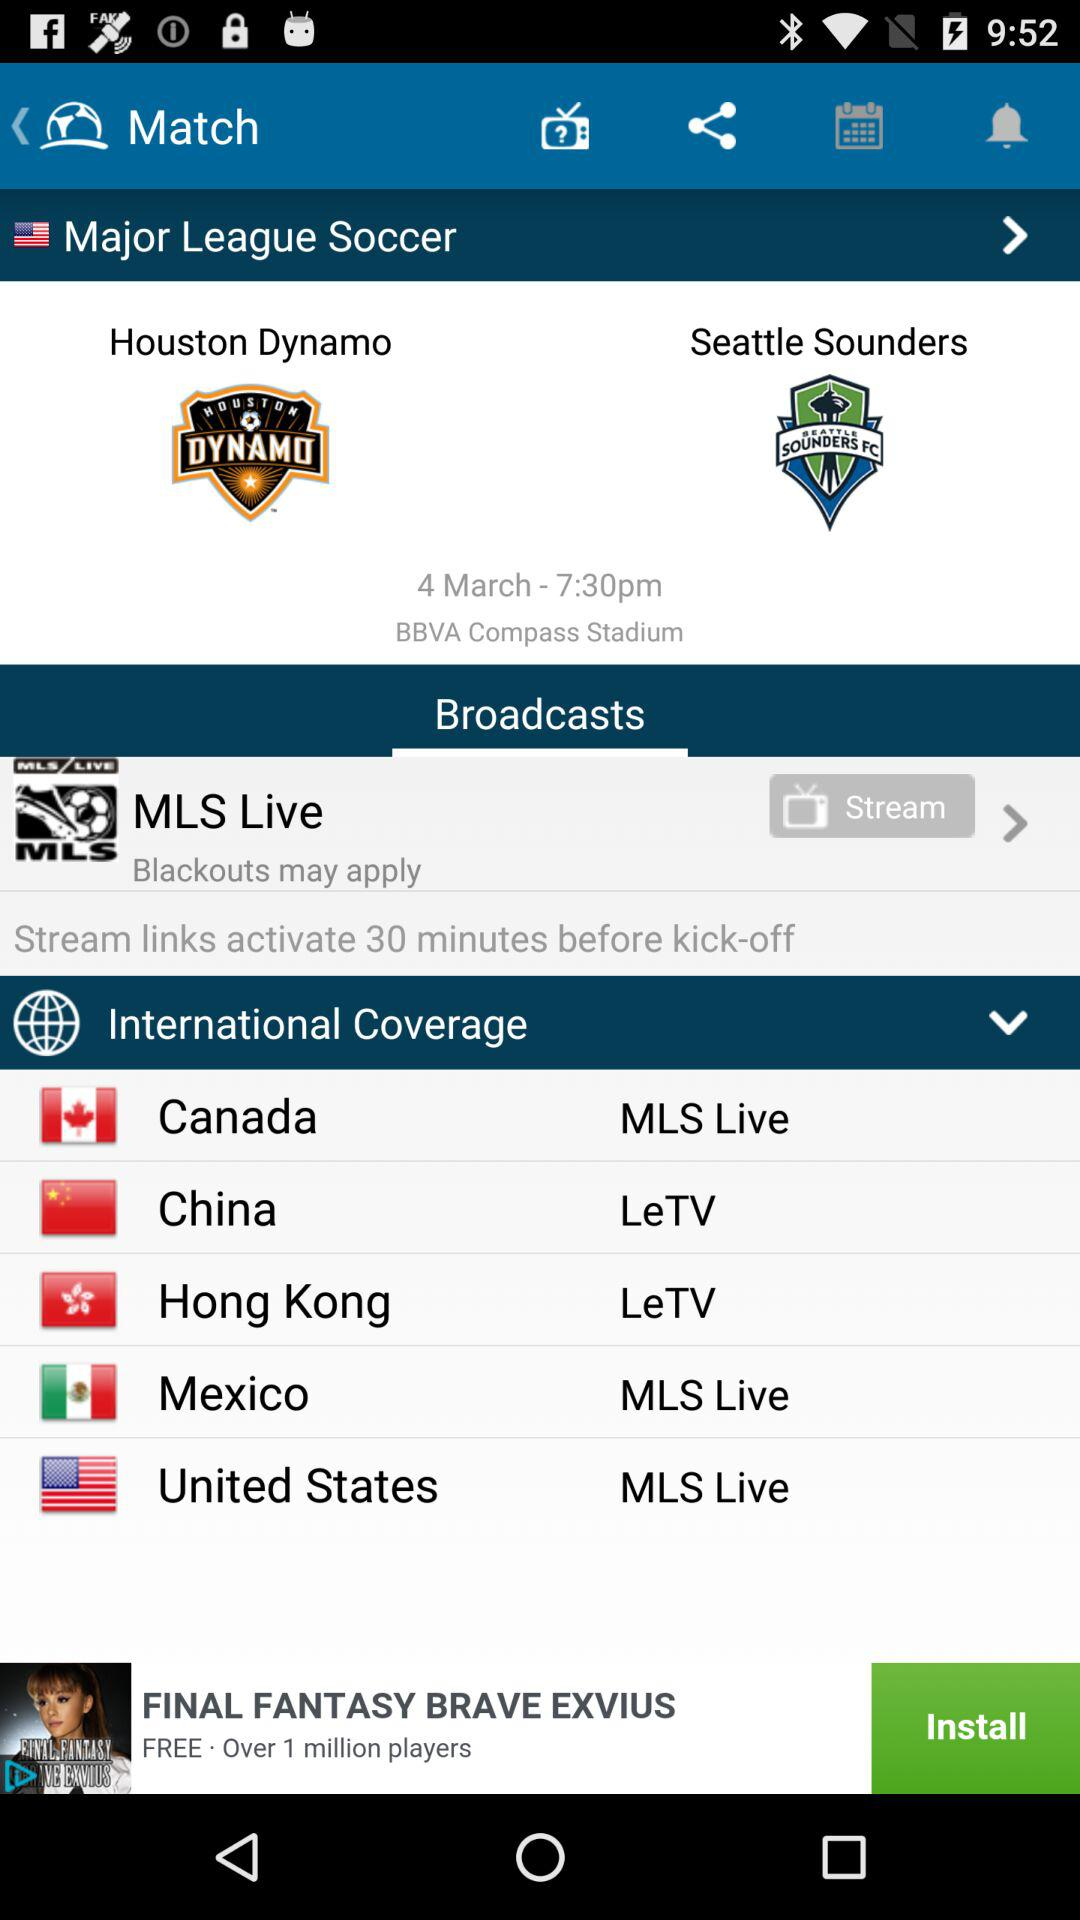How many teams are playing in the match?
Answer the question using a single word or phrase. 2 